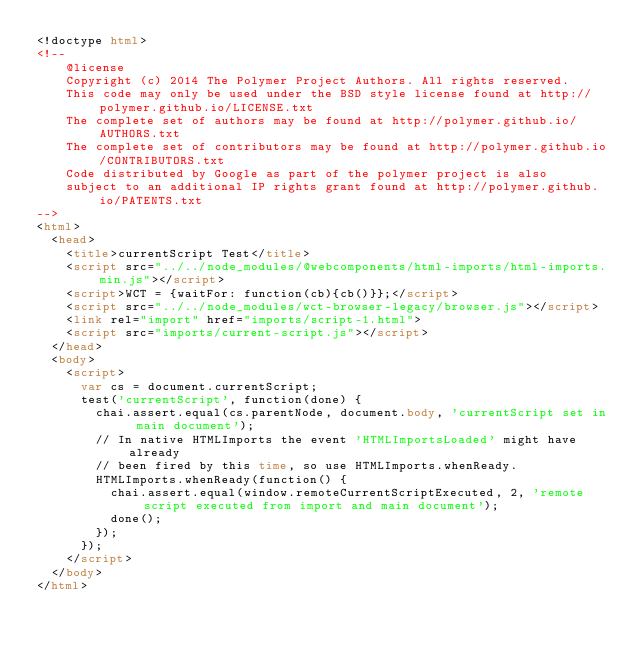Convert code to text. <code><loc_0><loc_0><loc_500><loc_500><_HTML_><!doctype html>
<!--
    @license
    Copyright (c) 2014 The Polymer Project Authors. All rights reserved.
    This code may only be used under the BSD style license found at http://polymer.github.io/LICENSE.txt
    The complete set of authors may be found at http://polymer.github.io/AUTHORS.txt
    The complete set of contributors may be found at http://polymer.github.io/CONTRIBUTORS.txt
    Code distributed by Google as part of the polymer project is also
    subject to an additional IP rights grant found at http://polymer.github.io/PATENTS.txt
-->
<html>
  <head>
    <title>currentScript Test</title>
    <script src="../../node_modules/@webcomponents/html-imports/html-imports.min.js"></script>
    <script>WCT = {waitFor: function(cb){cb()}};</script>
    <script src="../../node_modules/wct-browser-legacy/browser.js"></script>
    <link rel="import" href="imports/script-1.html">
    <script src="imports/current-script.js"></script>
  </head>
  <body>
    <script>
      var cs = document.currentScript;
      test('currentScript', function(done) {
        chai.assert.equal(cs.parentNode, document.body, 'currentScript set in main document');
        // In native HTMLImports the event 'HTMLImportsLoaded' might have already
        // been fired by this time, so use HTMLImports.whenReady.
        HTMLImports.whenReady(function() {
          chai.assert.equal(window.remoteCurrentScriptExecuted, 2, 'remote script executed from import and main document');
          done();
        });
      });
    </script>
  </body>
</html>
</code> 